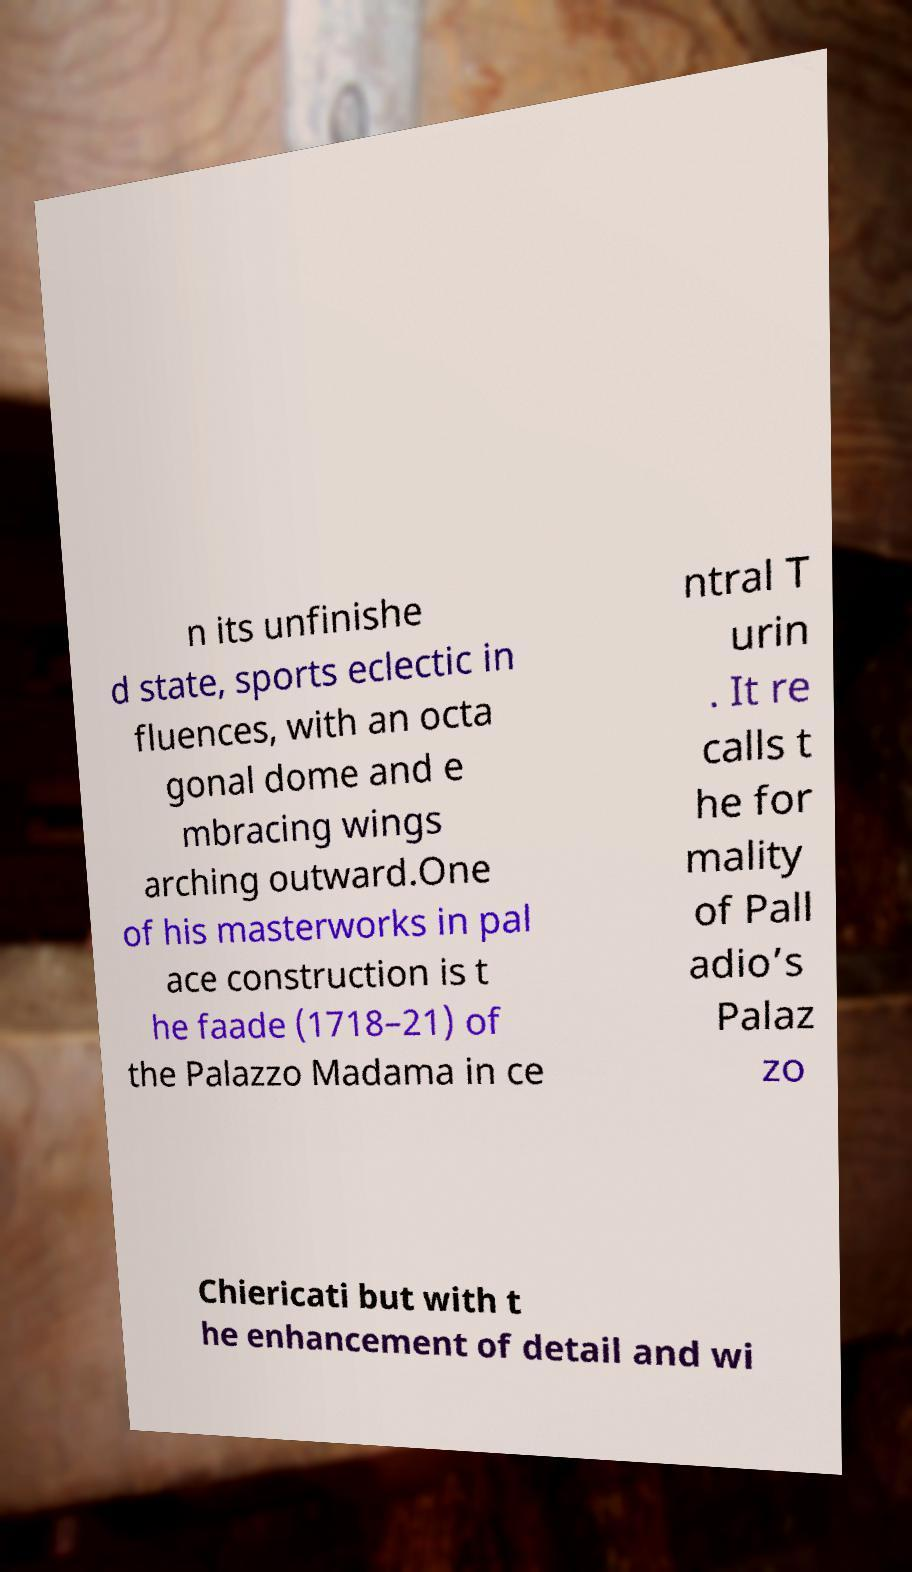There's text embedded in this image that I need extracted. Can you transcribe it verbatim? n its unfinishe d state, sports eclectic in fluences, with an octa gonal dome and e mbracing wings arching outward.One of his masterworks in pal ace construction is t he faade (1718–21) of the Palazzo Madama in ce ntral T urin . It re calls t he for mality of Pall adio’s Palaz zo Chiericati but with t he enhancement of detail and wi 